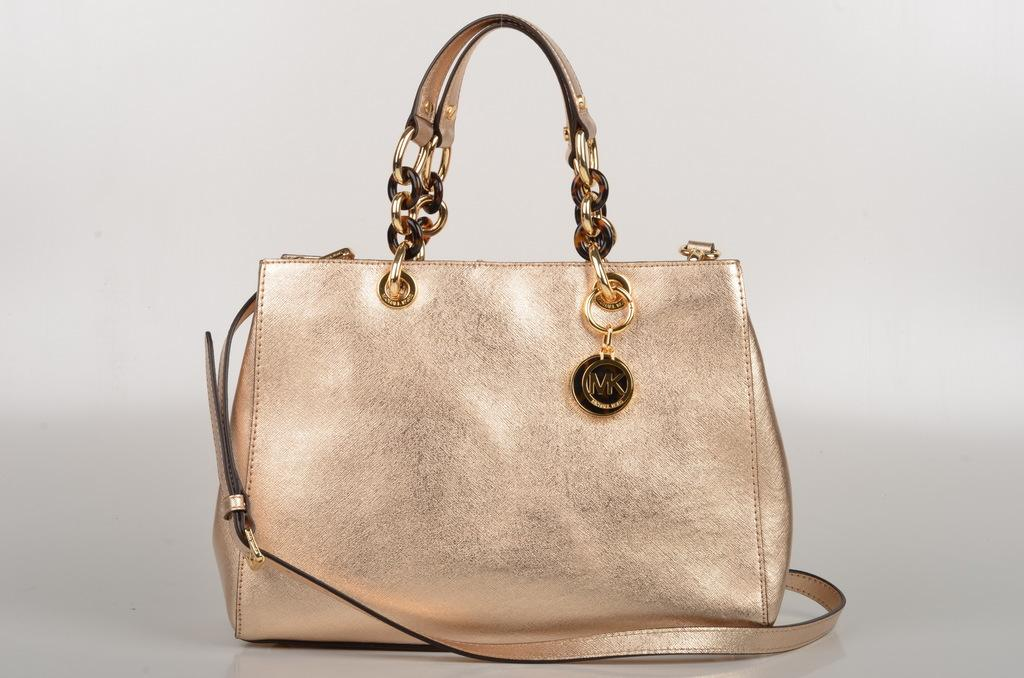What object is present in the picture? There is a handbag in the picture. What is the color of the handbag? The handbag is light pink in color. Is there anything attached to the handbag? Yes, there is a key chain attached to the handbag. How can the handbag be carried? The handbag has a strap, which allows it to be carried over the shoulder or in the hand. How many times did the handbag kiss the person in the image? There is no kissing activity involving the handbag in the image. 